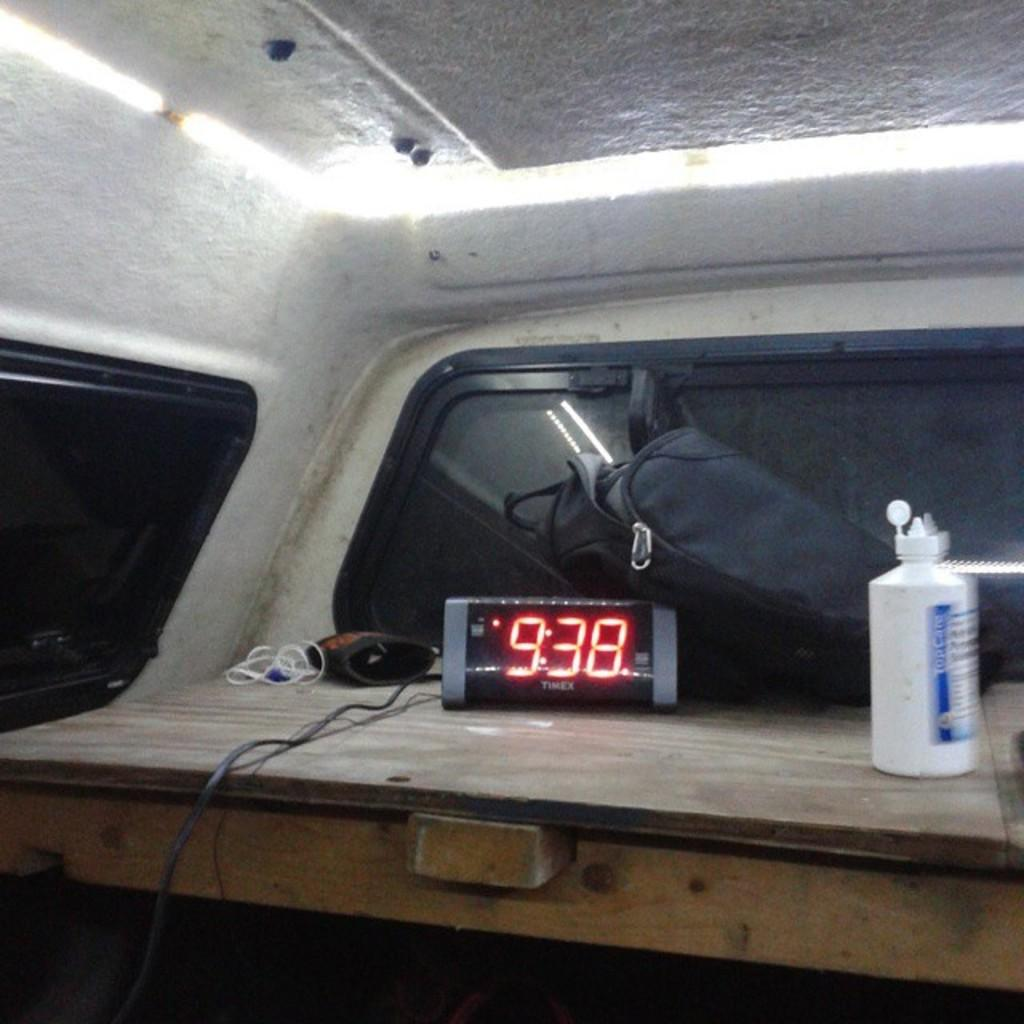What object in the image is used for measuring time? There is a clock in the image that is used for measuring time. What object in the image might be used for carrying items? There is a bag in the image that might be used for carrying items. What object in the image might be used for holding a liquid? There is a bottle in the image that might be used for holding a liquid. What type of architectural feature is present in the image? There is a glass window in the image, which is an architectural feature. What type of division can be seen in the image? There is no division present in the image; it features a clock, a bag, a bottle, and a glass window. Can you tell me how many cemeteries are visible in the image? There are no cemeteries present in the image. 